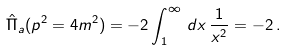Convert formula to latex. <formula><loc_0><loc_0><loc_500><loc_500>\hat { \Pi } _ { a } ( p ^ { 2 } = 4 m ^ { 2 } ) = - 2 \int _ { 1 } ^ { \infty } \, d x \, \frac { 1 } { x ^ { 2 } } = - 2 \, .</formula> 